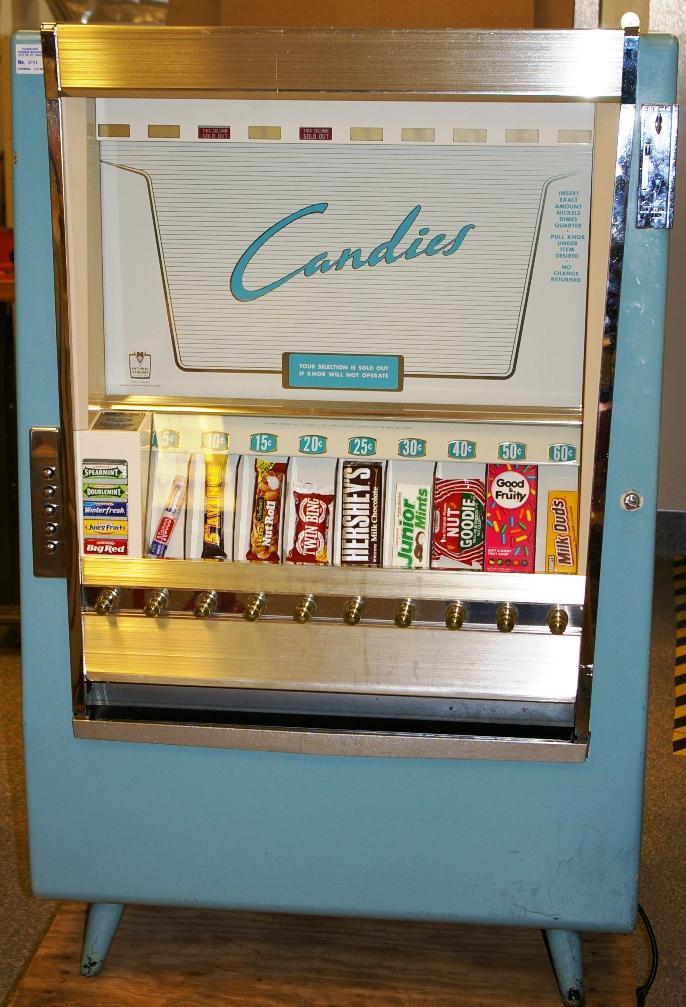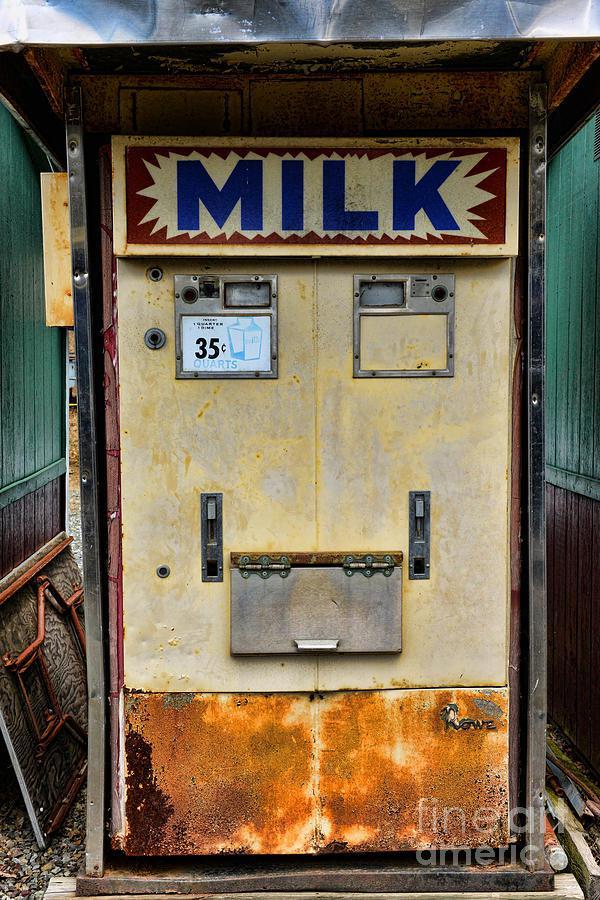The first image is the image on the left, the second image is the image on the right. For the images displayed, is the sentence "Knobs can be seen beneath a single row of candies on the vending machine in one of the images." factually correct? Answer yes or no. Yes. 